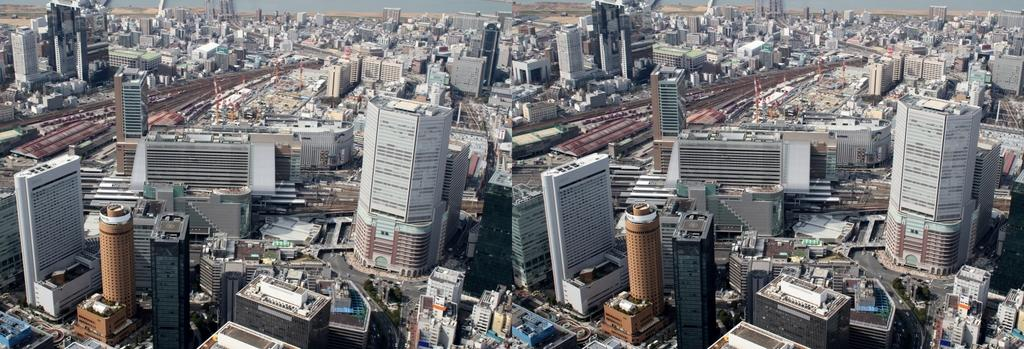What type of structures can be seen in the image? There are buildings in the image. What else is present in the image besides the buildings? There is a road and vehicles visible in the image. What color of the coat worn by the hair in the image? There is no hair or coat present in the image; it features buildings, a road, and vehicles. 